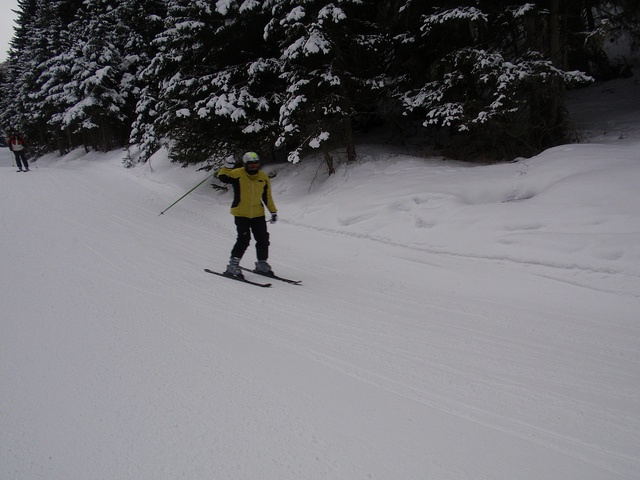Describe the objects in this image and their specific colors. I can see people in lightgray, black, olive, and gray tones, skis in lightgray, black, darkgray, and gray tones, and people in lightgray, black, and gray tones in this image. 